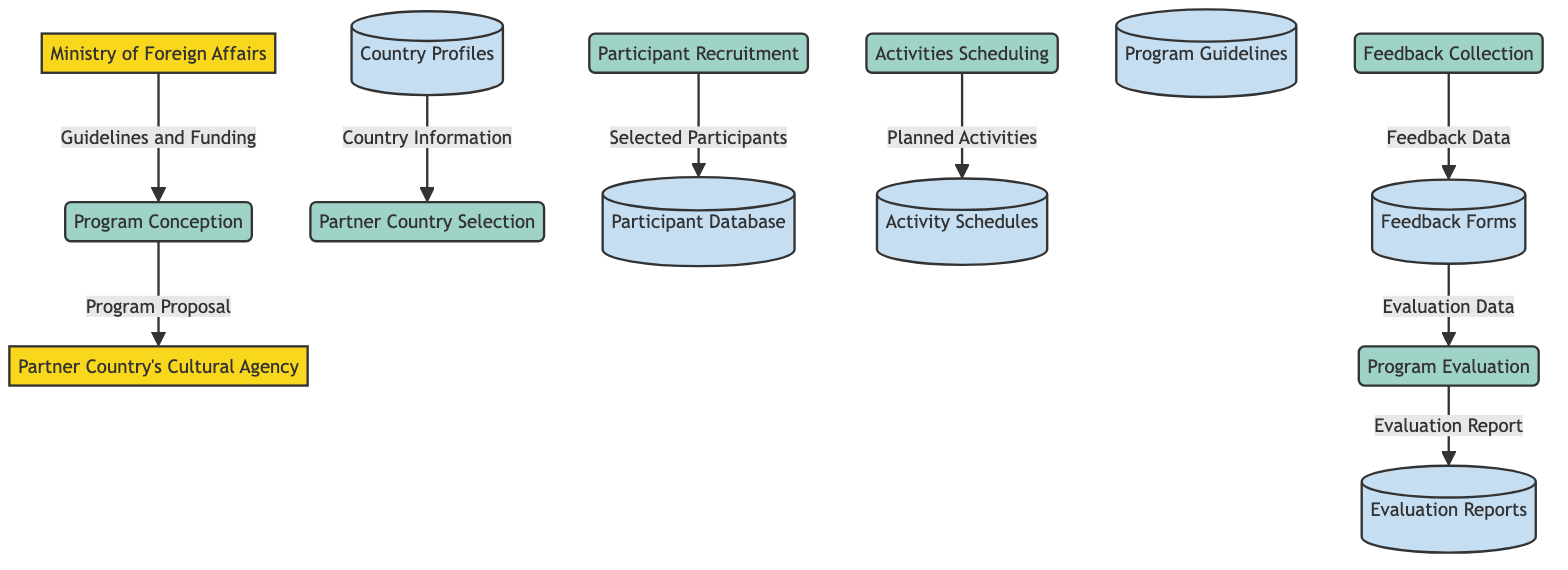What are the two external entities in the diagram? The diagram lists "Ministry of Foreign Affairs" and "Partner Country's Cultural Agency" as the external entities involved in the cultural exchange program.
Answer: Ministry of Foreign Affairs, Partner Country's Cultural Agency How many processes are defined in this diagram? The diagram contains six distinct processes which detail various stages of managing the cultural exchange program.
Answer: 6 What data flows into the "Program Conception" process? The only data flow into the "Program Conception" process is "Guidelines and Funding," which originates from the Ministry of Foreign Affairs, indicating the start of the program development.
Answer: Guidelines and Funding Which data store is updated with participant information? The "Participant Database" is the data store that receives updated information about selected participants from the "Participant Recruitment" process.
Answer: Participant Database What is the output of the "Program Evaluation" process? The output of the "Program Evaluation" process is the "Evaluation Report," which contains the compiled analysis of the program's success and areas for improvement.
Answer: Evaluation Report What comes after "Feedback Collection" in the flow? After "Feedback Collection," the next step in the flow is "Program Evaluation," which uses the collected feedback to assess the program's effectiveness.
Answer: Program Evaluation What is the relation between "Feedback Forms" and "Program Evaluation"? "Feedback Forms" supply the necessary data used in the "Program Evaluation" process to assess the success of the cultural exchange program.
Answer: Feedback Forms supply data From which process does the "Program Proposal" originate? The "Program Proposal" originates from the "Program Conception" process, where the program framework is developed and subsequently shared with the partner country.
Answer: Program Conception 